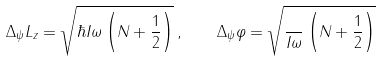Convert formula to latex. <formula><loc_0><loc_0><loc_500><loc_500>\Delta _ { \psi } L _ { z } = \sqrt { \hbar { I } \omega \left ( { N + \frac { 1 } { 2 } } \right ) } \, , \quad \Delta _ { \psi } \varphi = \sqrt { \frac { } { I \omega } \left ( { N + \frac { 1 } { 2 } } \right ) }</formula> 